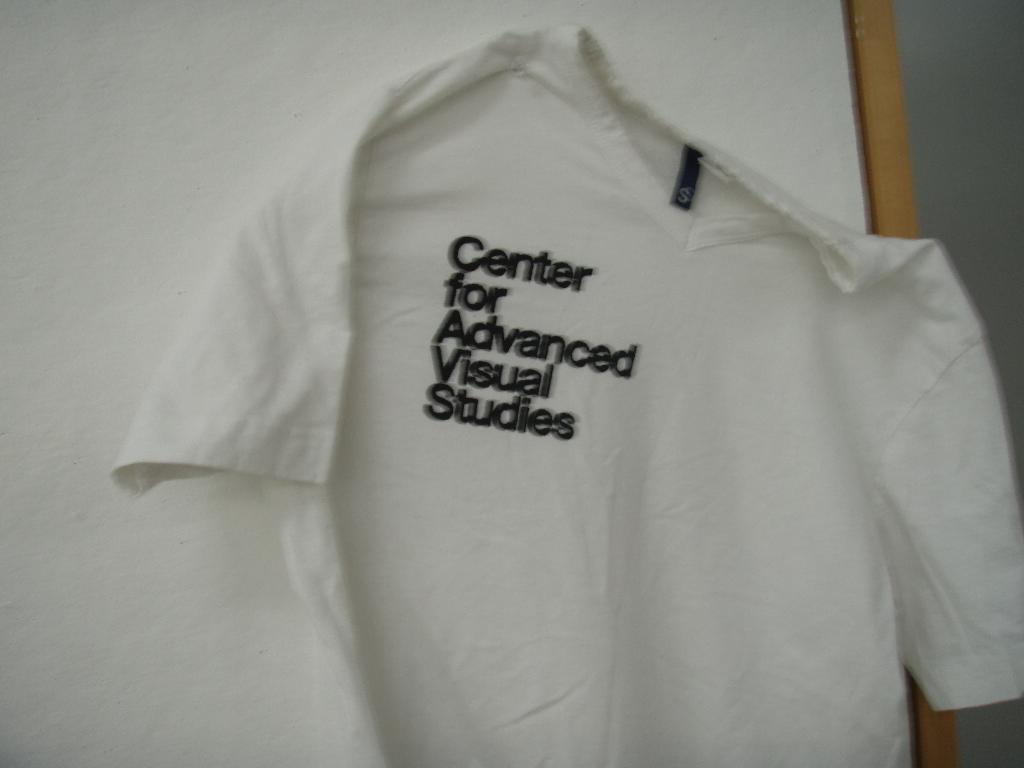Provide a one-sentence caption for the provided image. A white t-shirt advertises the Center for Advanced Visual Studies. 